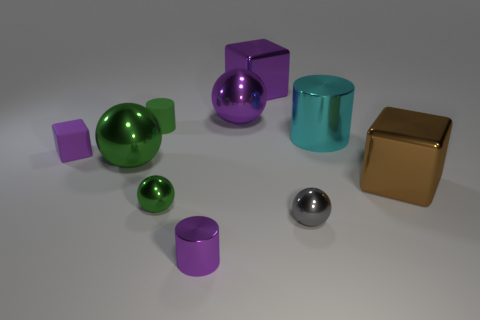How many small metal cylinders have the same color as the large shiny cylinder?
Ensure brevity in your answer.  0. Is the number of shiny objects less than the number of big cylinders?
Make the answer very short. No. Are the small green sphere and the green cylinder made of the same material?
Keep it short and to the point. No. How many other objects are there of the same size as the brown shiny thing?
Your answer should be compact. 4. The shiny cylinder that is in front of the green metallic object in front of the brown thing is what color?
Provide a short and direct response. Purple. How many other things are the same shape as the gray object?
Give a very brief answer. 3. Are there any purple cubes that have the same material as the large cyan cylinder?
Your answer should be compact. Yes. There is a green sphere that is the same size as the brown shiny cube; what is its material?
Ensure brevity in your answer.  Metal. What is the color of the small thing that is in front of the small shiny sphere to the right of the shiny block behind the tiny block?
Provide a short and direct response. Purple. There is a green object in front of the large brown cube; does it have the same shape as the tiny metallic object that is in front of the tiny gray thing?
Provide a succinct answer. No. 